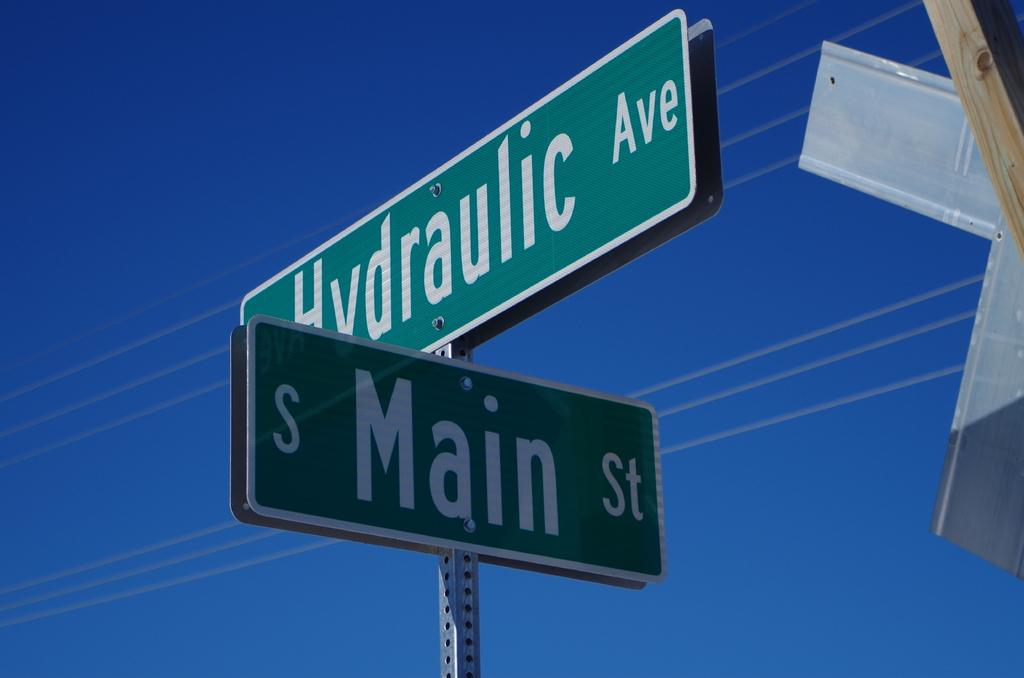<image>
Summarize the visual content of the image. The intersection of Main St and Hydraulic. Av 